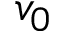<formula> <loc_0><loc_0><loc_500><loc_500>v _ { 0 }</formula> 